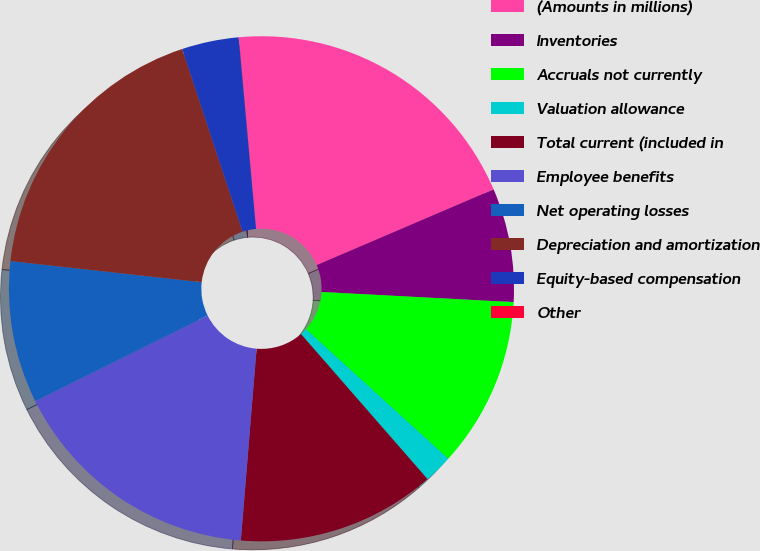Convert chart to OTSL. <chart><loc_0><loc_0><loc_500><loc_500><pie_chart><fcel>(Amounts in millions)<fcel>Inventories<fcel>Accruals not currently<fcel>Valuation allowance<fcel>Total current (included in<fcel>Employee benefits<fcel>Net operating losses<fcel>Depreciation and amortization<fcel>Equity-based compensation<fcel>Other<nl><fcel>19.99%<fcel>7.28%<fcel>10.91%<fcel>1.83%<fcel>12.72%<fcel>16.36%<fcel>9.09%<fcel>18.17%<fcel>3.64%<fcel>0.01%<nl></chart> 